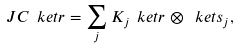<formula> <loc_0><loc_0><loc_500><loc_500>\ J C \ k e t { r } = \sum _ { j } K _ { j } \ k e t { r } \otimes \ k e t { s _ { j } } ,</formula> 